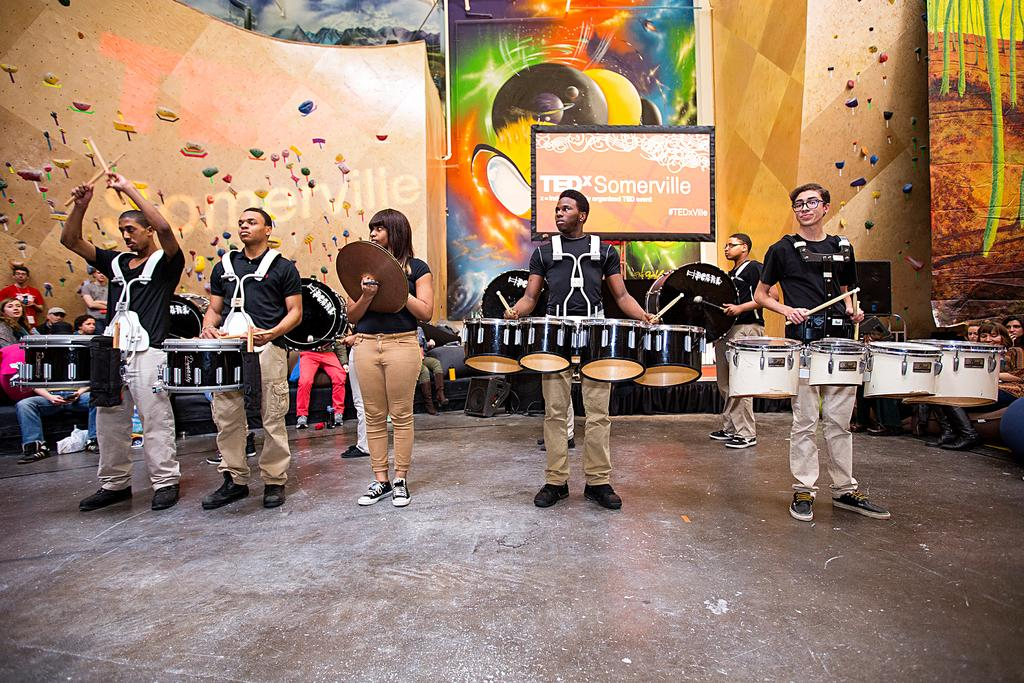What are the people in the image doing? Some of the people are playing musical instruments. Can you describe the people in the background of the image? There are people visible in the background of the image. What objects can be seen in the background of the image? There are screens and boards visible in the background of the image. How does the fog affect the visibility of the people playing musical instruments in the image? There is no fog present in the image, so it does not affect the visibility of the people playing musical instruments. 